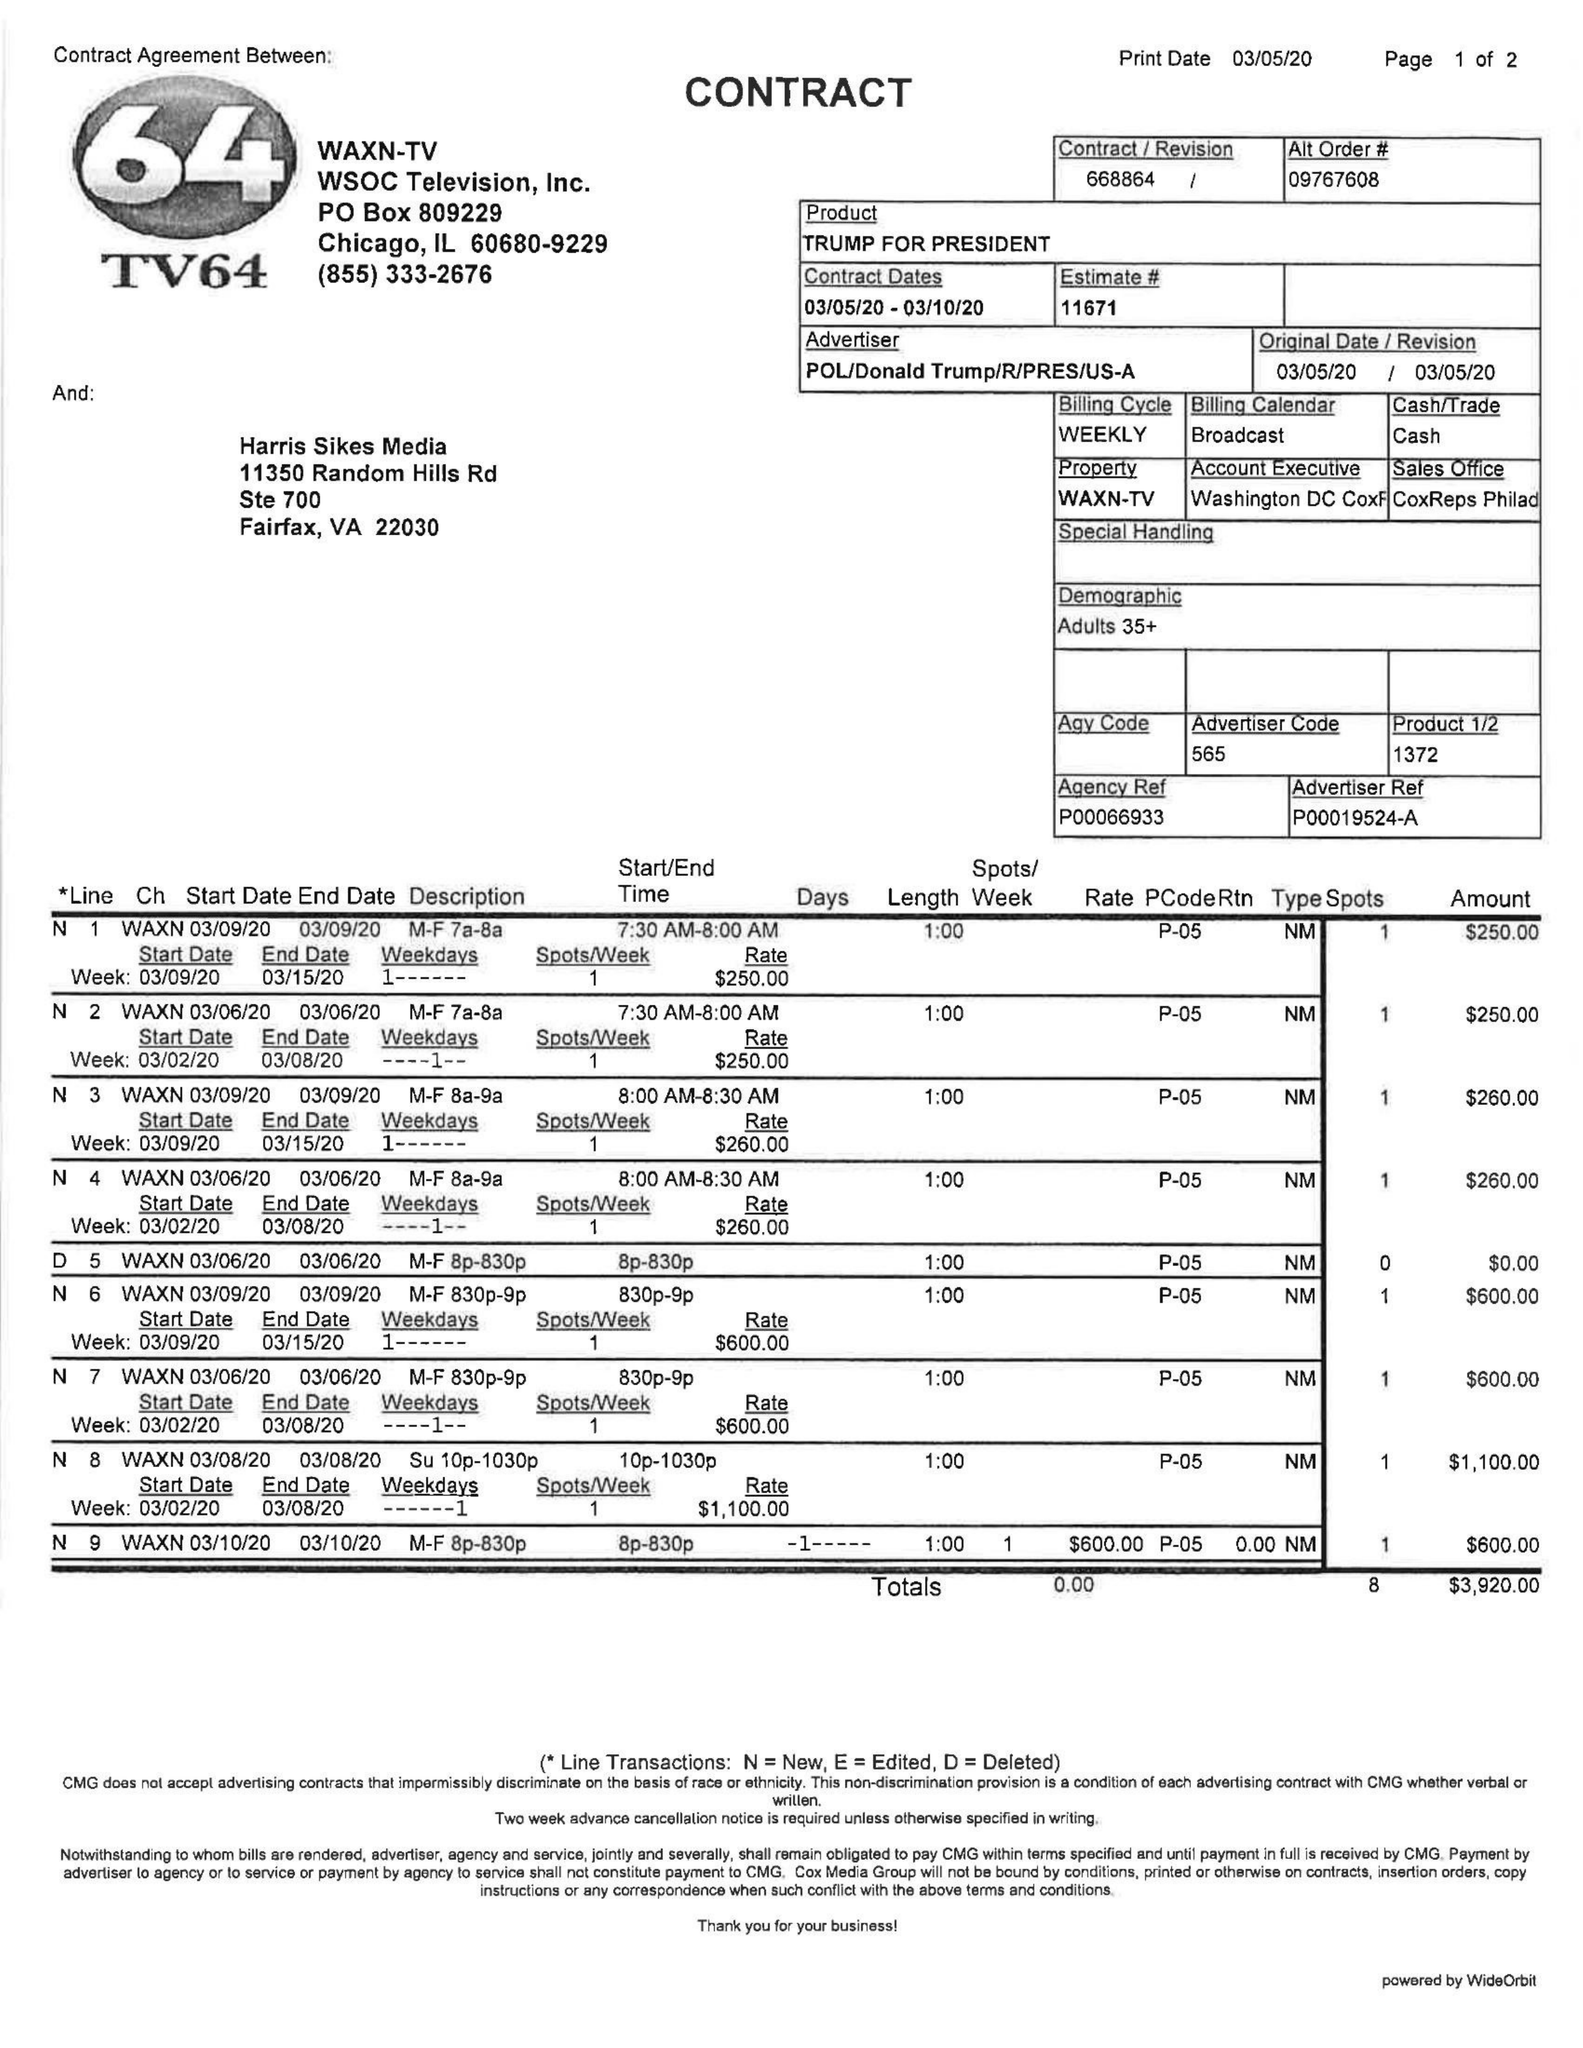What is the value for the flight_from?
Answer the question using a single word or phrase. 03/05/20 